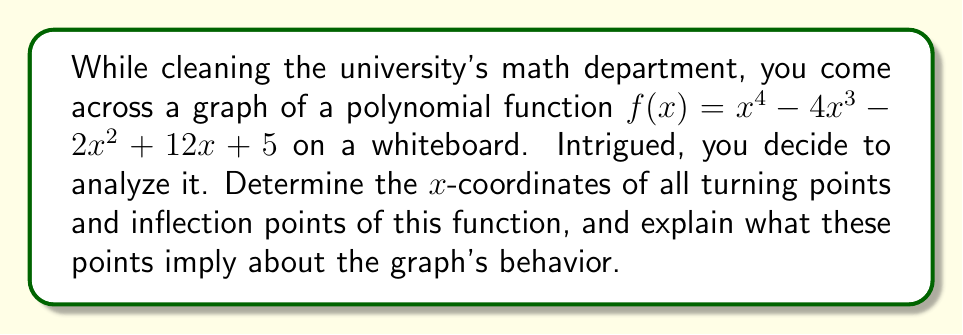Teach me how to tackle this problem. To find turning points and inflection points, we need to analyze the derivatives of the function.

Step 1: Find the first derivative
$f'(x) = 4x^3 - 12x^2 - 4x + 12$

Step 2: Find the second derivative
$f''(x) = 12x^2 - 24x - 4$

Step 3: Find turning points by solving $f'(x) = 0$
$4x^3 - 12x^2 - 4x + 12 = 0$
$(2x - 3)(2x^2 - 3x - 4) = 0$
$x = \frac{3}{2}$ or $x = 2$ or $x = -1$

Step 4: Find inflection points by solving $f''(x) = 0$
$12x^2 - 24x - 4 = 0$
$3x^2 - 6x - 1 = 0$
$x = \frac{3 \pm \sqrt{11}}{3}$

Step 5: Interpret the results
Turning points:
- At $x = -1$: local maximum (concave down)
- At $x = \frac{3}{2}$: local minimum (concave up)
- At $x = 2$: local maximum (concave down)

Inflection points:
- At $x = \frac{3 - \sqrt{11}}{3} \approx 0.232$: concavity changes from up to down
- At $x = \frac{3 + \sqrt{11}}{3} \approx 1.768$: concavity changes from down to up

These points imply that the graph:
1. Increases until $x = -1$, then decreases
2. Reaches a local minimum at $x = \frac{3}{2}$, then increases
3. Reaches another local maximum at $x = 2$, then decreases
4. Changes concavity twice, at $x \approx 0.232$ and $x \approx 1.768$
Answer: Turning points: $(-1, \text{max}), (\frac{3}{2}, \text{min}), (2, \text{max})$
Inflection points: $(\frac{3 - \sqrt{11}}{3}, \text{down}), (\frac{3 + \sqrt{11}}{3}, \text{up})$ 